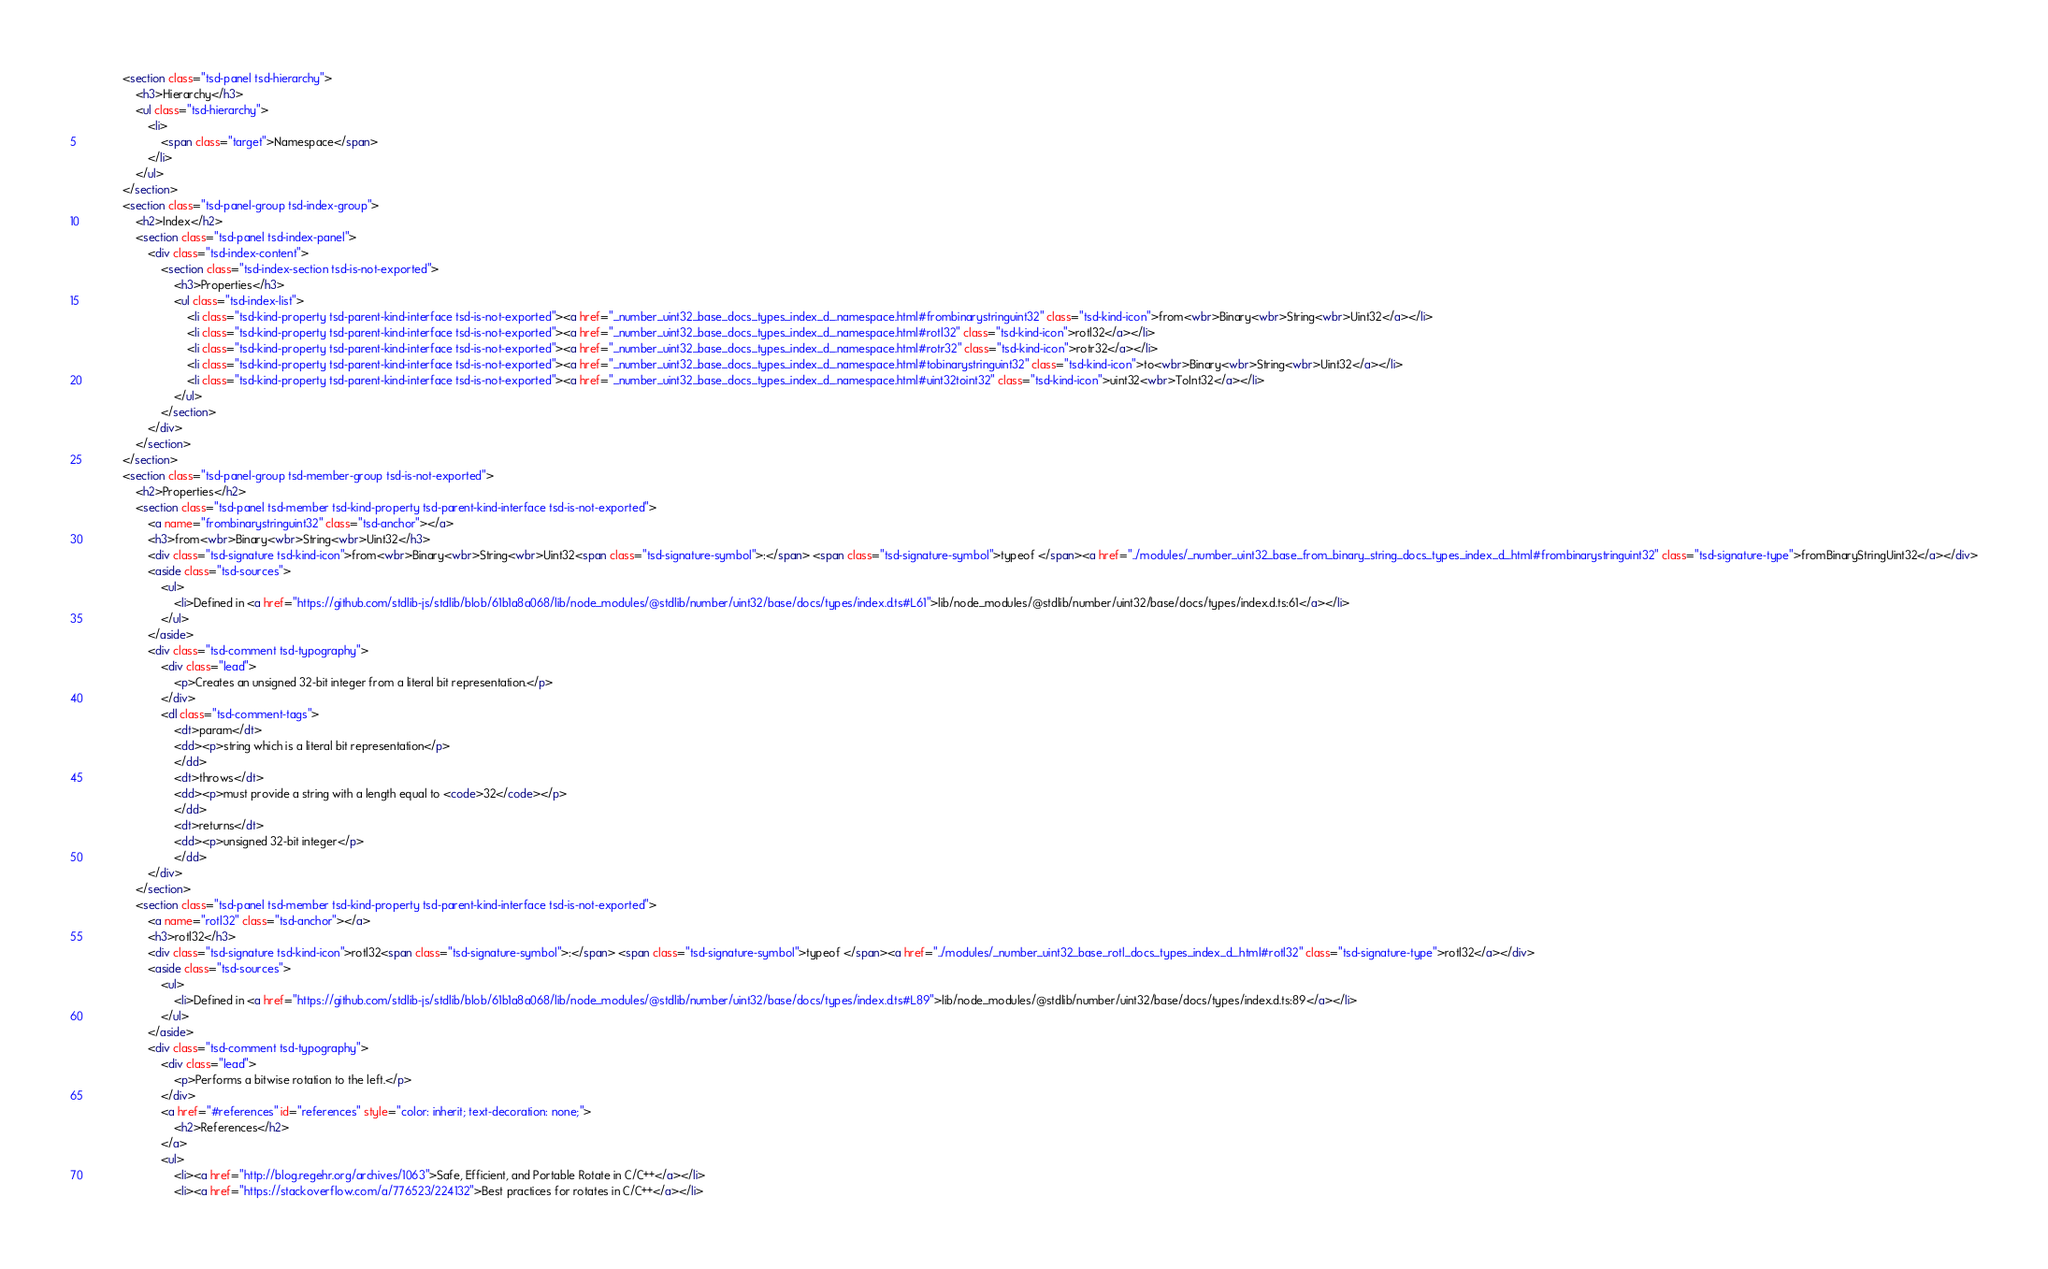<code> <loc_0><loc_0><loc_500><loc_500><_HTML_>			<section class="tsd-panel tsd-hierarchy">
				<h3>Hierarchy</h3>
				<ul class="tsd-hierarchy">
					<li>
						<span class="target">Namespace</span>
					</li>
				</ul>
			</section>
			<section class="tsd-panel-group tsd-index-group">
				<h2>Index</h2>
				<section class="tsd-panel tsd-index-panel">
					<div class="tsd-index-content">
						<section class="tsd-index-section tsd-is-not-exported">
							<h3>Properties</h3>
							<ul class="tsd-index-list">
								<li class="tsd-kind-property tsd-parent-kind-interface tsd-is-not-exported"><a href="_number_uint32_base_docs_types_index_d_.namespace.html#frombinarystringuint32" class="tsd-kind-icon">from<wbr>Binary<wbr>String<wbr>Uint32</a></li>
								<li class="tsd-kind-property tsd-parent-kind-interface tsd-is-not-exported"><a href="_number_uint32_base_docs_types_index_d_.namespace.html#rotl32" class="tsd-kind-icon">rotl32</a></li>
								<li class="tsd-kind-property tsd-parent-kind-interface tsd-is-not-exported"><a href="_number_uint32_base_docs_types_index_d_.namespace.html#rotr32" class="tsd-kind-icon">rotr32</a></li>
								<li class="tsd-kind-property tsd-parent-kind-interface tsd-is-not-exported"><a href="_number_uint32_base_docs_types_index_d_.namespace.html#tobinarystringuint32" class="tsd-kind-icon">to<wbr>Binary<wbr>String<wbr>Uint32</a></li>
								<li class="tsd-kind-property tsd-parent-kind-interface tsd-is-not-exported"><a href="_number_uint32_base_docs_types_index_d_.namespace.html#uint32toint32" class="tsd-kind-icon">uint32<wbr>ToInt32</a></li>
							</ul>
						</section>
					</div>
				</section>
			</section>
			<section class="tsd-panel-group tsd-member-group tsd-is-not-exported">
				<h2>Properties</h2>
				<section class="tsd-panel tsd-member tsd-kind-property tsd-parent-kind-interface tsd-is-not-exported">
					<a name="frombinarystringuint32" class="tsd-anchor"></a>
					<h3>from<wbr>Binary<wbr>String<wbr>Uint32</h3>
					<div class="tsd-signature tsd-kind-icon">from<wbr>Binary<wbr>String<wbr>Uint32<span class="tsd-signature-symbol">:</span> <span class="tsd-signature-symbol">typeof </span><a href="../modules/_number_uint32_base_from_binary_string_docs_types_index_d_.html#frombinarystringuint32" class="tsd-signature-type">fromBinaryStringUint32</a></div>
					<aside class="tsd-sources">
						<ul>
							<li>Defined in <a href="https://github.com/stdlib-js/stdlib/blob/61b1a8a068/lib/node_modules/@stdlib/number/uint32/base/docs/types/index.d.ts#L61">lib/node_modules/@stdlib/number/uint32/base/docs/types/index.d.ts:61</a></li>
						</ul>
					</aside>
					<div class="tsd-comment tsd-typography">
						<div class="lead">
							<p>Creates an unsigned 32-bit integer from a literal bit representation.</p>
						</div>
						<dl class="tsd-comment-tags">
							<dt>param</dt>
							<dd><p>string which is a literal bit representation</p>
							</dd>
							<dt>throws</dt>
							<dd><p>must provide a string with a length equal to <code>32</code></p>
							</dd>
							<dt>returns</dt>
							<dd><p>unsigned 32-bit integer</p>
							</dd>
					</div>
				</section>
				<section class="tsd-panel tsd-member tsd-kind-property tsd-parent-kind-interface tsd-is-not-exported">
					<a name="rotl32" class="tsd-anchor"></a>
					<h3>rotl32</h3>
					<div class="tsd-signature tsd-kind-icon">rotl32<span class="tsd-signature-symbol">:</span> <span class="tsd-signature-symbol">typeof </span><a href="../modules/_number_uint32_base_rotl_docs_types_index_d_.html#rotl32" class="tsd-signature-type">rotl32</a></div>
					<aside class="tsd-sources">
						<ul>
							<li>Defined in <a href="https://github.com/stdlib-js/stdlib/blob/61b1a8a068/lib/node_modules/@stdlib/number/uint32/base/docs/types/index.d.ts#L89">lib/node_modules/@stdlib/number/uint32/base/docs/types/index.d.ts:89</a></li>
						</ul>
					</aside>
					<div class="tsd-comment tsd-typography">
						<div class="lead">
							<p>Performs a bitwise rotation to the left.</p>
						</div>
						<a href="#references" id="references" style="color: inherit; text-decoration: none;">
							<h2>References</h2>
						</a>
						<ul>
							<li><a href="http://blog.regehr.org/archives/1063">Safe, Efficient, and Portable Rotate in C/C++</a></li>
							<li><a href="https://stackoverflow.com/a/776523/224132">Best practices for rotates in C/C++</a></li></code> 